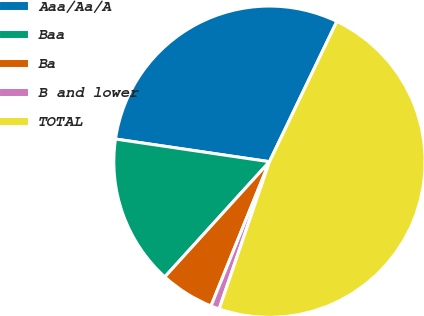<chart> <loc_0><loc_0><loc_500><loc_500><pie_chart><fcel>Aaa/Aa/A<fcel>Baa<fcel>Ba<fcel>B and lower<fcel>TOTAL<nl><fcel>29.8%<fcel>15.59%<fcel>5.61%<fcel>0.89%<fcel>48.11%<nl></chart> 